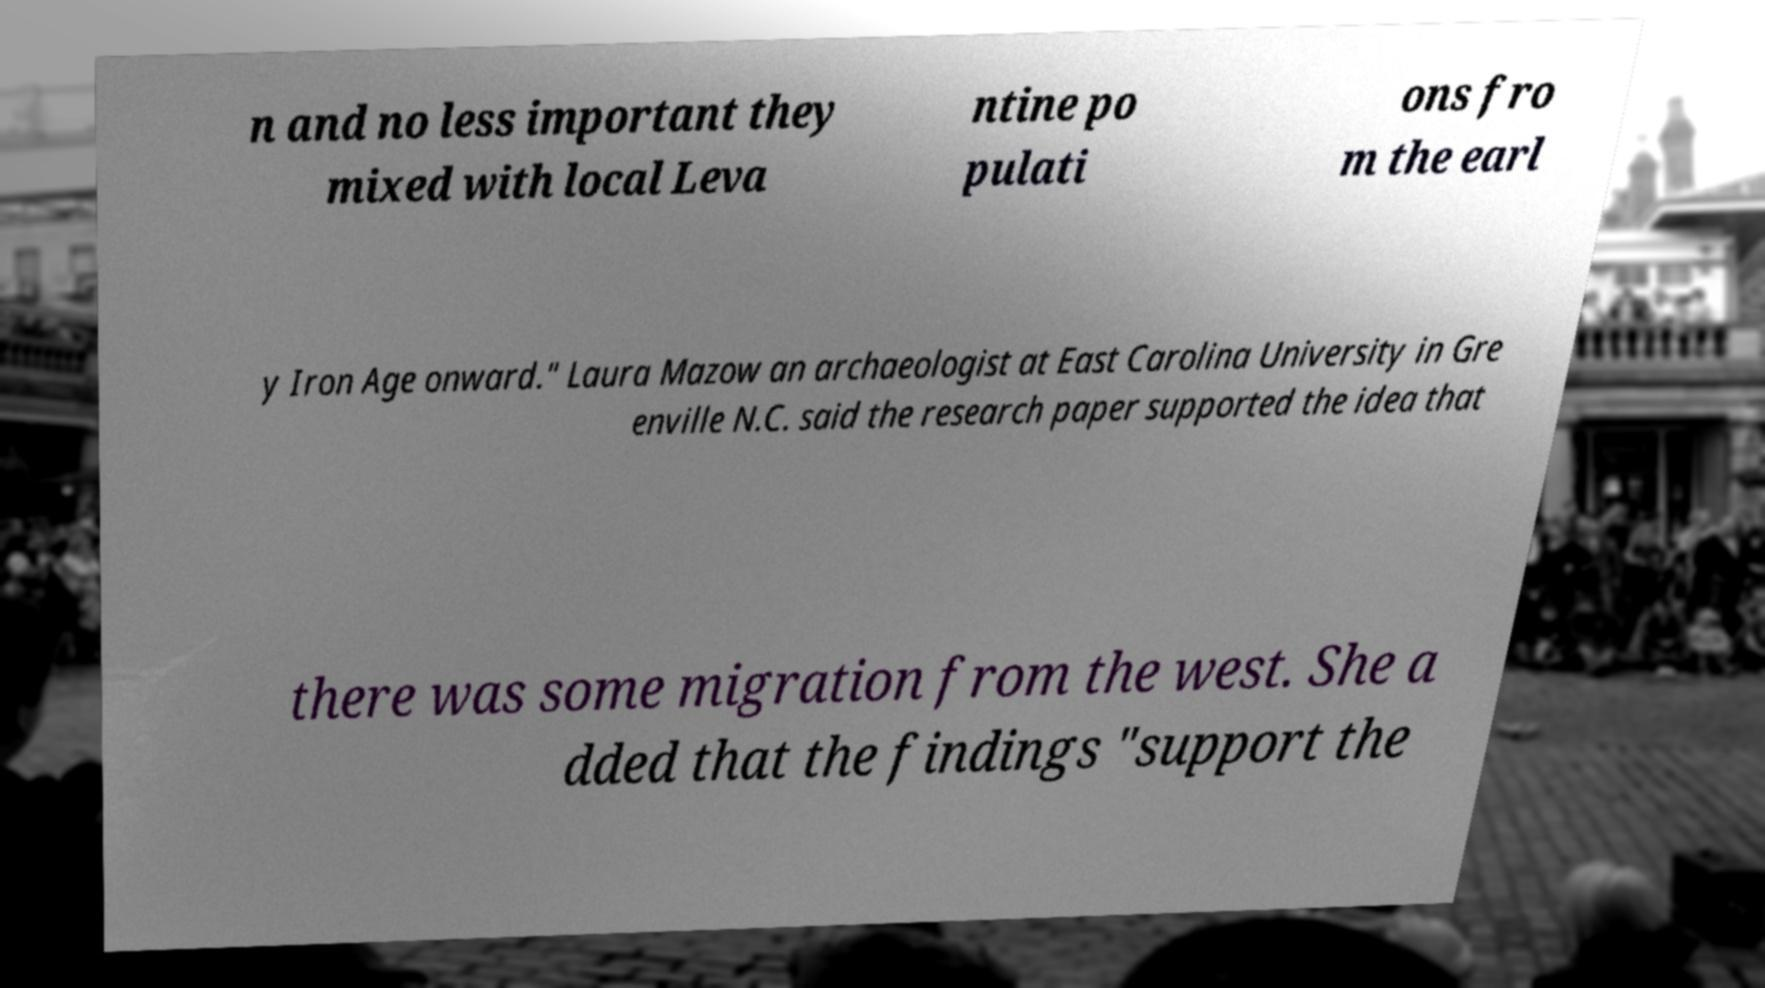Can you read and provide the text displayed in the image?This photo seems to have some interesting text. Can you extract and type it out for me? n and no less important they mixed with local Leva ntine po pulati ons fro m the earl y Iron Age onward." Laura Mazow an archaeologist at East Carolina University in Gre enville N.C. said the research paper supported the idea that there was some migration from the west. She a dded that the findings "support the 